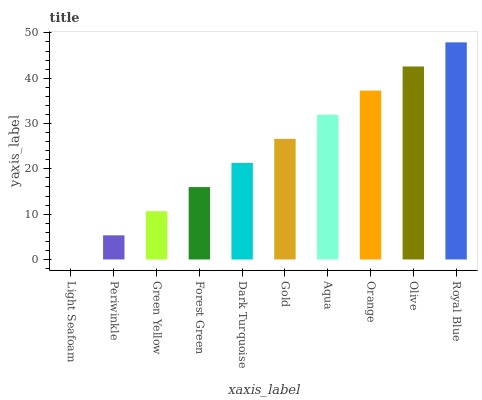Is Light Seafoam the minimum?
Answer yes or no. Yes. Is Royal Blue the maximum?
Answer yes or no. Yes. Is Periwinkle the minimum?
Answer yes or no. No. Is Periwinkle the maximum?
Answer yes or no. No. Is Periwinkle greater than Light Seafoam?
Answer yes or no. Yes. Is Light Seafoam less than Periwinkle?
Answer yes or no. Yes. Is Light Seafoam greater than Periwinkle?
Answer yes or no. No. Is Periwinkle less than Light Seafoam?
Answer yes or no. No. Is Gold the high median?
Answer yes or no. Yes. Is Dark Turquoise the low median?
Answer yes or no. Yes. Is Green Yellow the high median?
Answer yes or no. No. Is Periwinkle the low median?
Answer yes or no. No. 